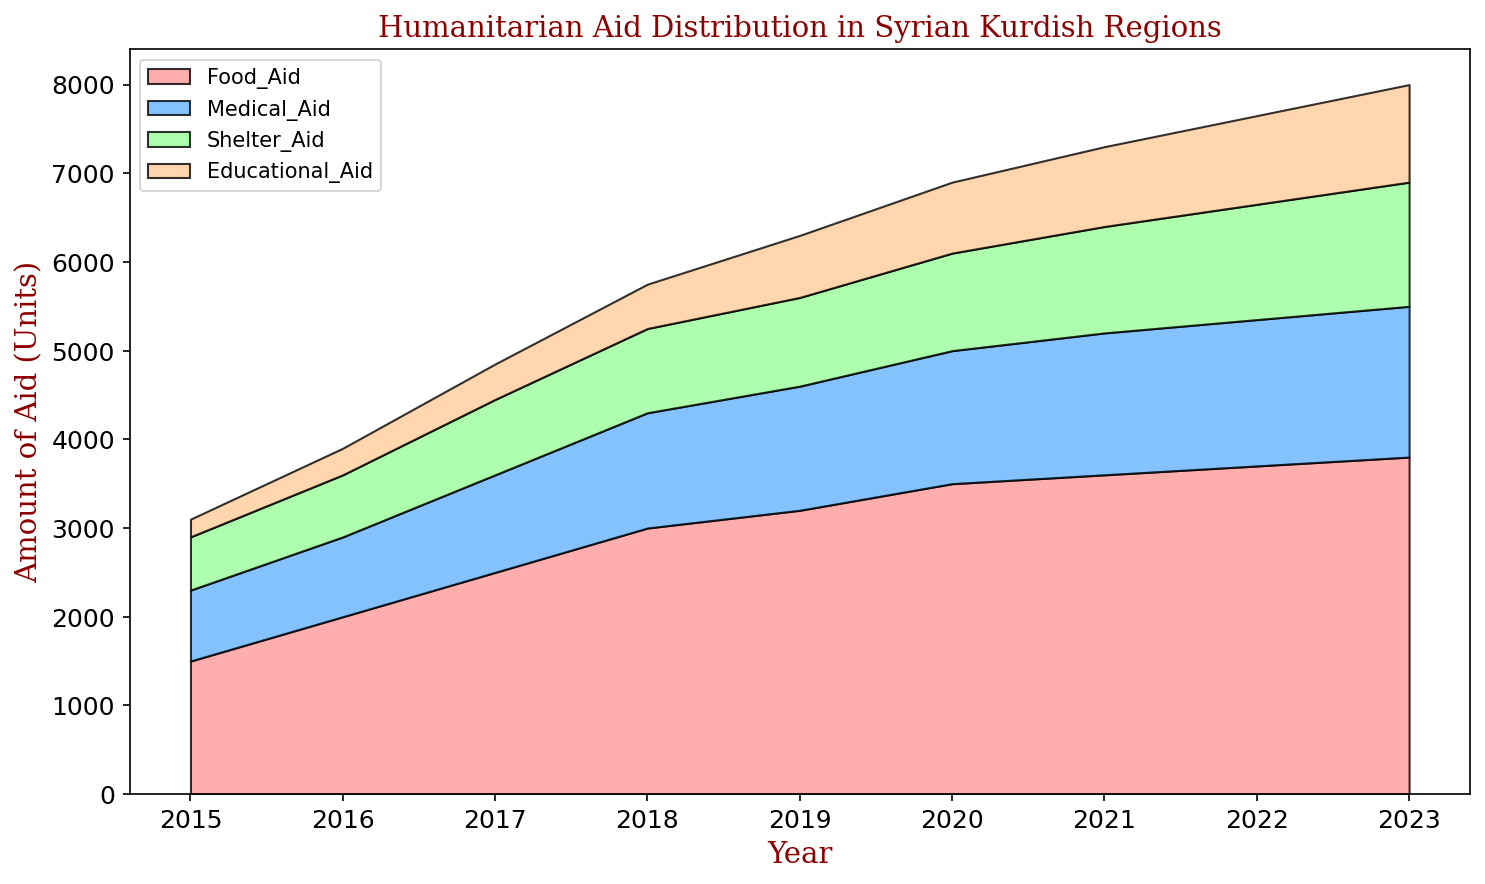What's the highest amount of educational aid distributed in any given year? The highest amount can be identified by observing the peaks in the educational aid section of the chart. The peak occurs in 2023, where the amount reaches 1100 units.
Answer: 1100 Which aid type had the most significant increase between 2015 and 2023? To determine this, compare the starting and ending values of each aid type. Food aid increased from 1500 to 3800 (2300 units). Medical aid increased from 800 to 1700 (900 units). Shelter aid increased from 600 to 1400 (800 units). Educational aid increased from 200 to 1100 (900 units). Food aid had the most significant increase.
Answer: Food aid In which year did medical aid surpass the 1000 unit mark? Identify the point where the medical aid data crosses the 1000 unit line. It first occurs between 2016 and 2017, with the exact value in 2017 being 1100 units.
Answer: 2017 By how much did shelter aid increase from 2018 to 2020? Find the values for shelter aid in 2018 (950 units) and 2020 (1100 units). The difference is 1100 - 950 = 150 units.
Answer: 150 Which year had the smallest increase in food aid compared to the previous year? Calculate the year-to-year differences for food aid: 2015-2016 (500), 2016-2017 (500), 2017-2018 (500), 2018-2019 (200), 2019-2020 (300), 2020-2021 (100), 2021-2022 (100), 2022-2023 (100). The smallest increase occurred from 2021 to 2022 and from 2022 to 2023 with an increase of 100 units.
Answer: 2021 to 2022, 2022 to 2023 Which type of aid has consistently received the least amount over the years? Compare the stacks of each aid type visually across all years. Educational aid always appears to be the smallest segment.
Answer: Educational aid What is the total amount of all types of aid distributed in 2022? Sum the values for each type of aid in 2022: Food (3700) + Medical (1650) + Shelter (1300) + Educational (1000) = 7650 units.
Answer: 7650 In which year did food aid show a significant increase relative to the previous year, vis-à-vis other aid types? A significant increase can be judged by the visual size of the food aid section. The most notable surge occurs between 2014 and 2015, and between 2017 and 2018.
Answer: 2018 